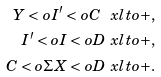<formula> <loc_0><loc_0><loc_500><loc_500>Y < o I ^ { \prime } < o C \ x l t o { + } , \\ I ^ { \prime } < o I < o D \ x l t o { + } , \\ C < o \Sigma X < o D \ x l t o { + } .</formula> 